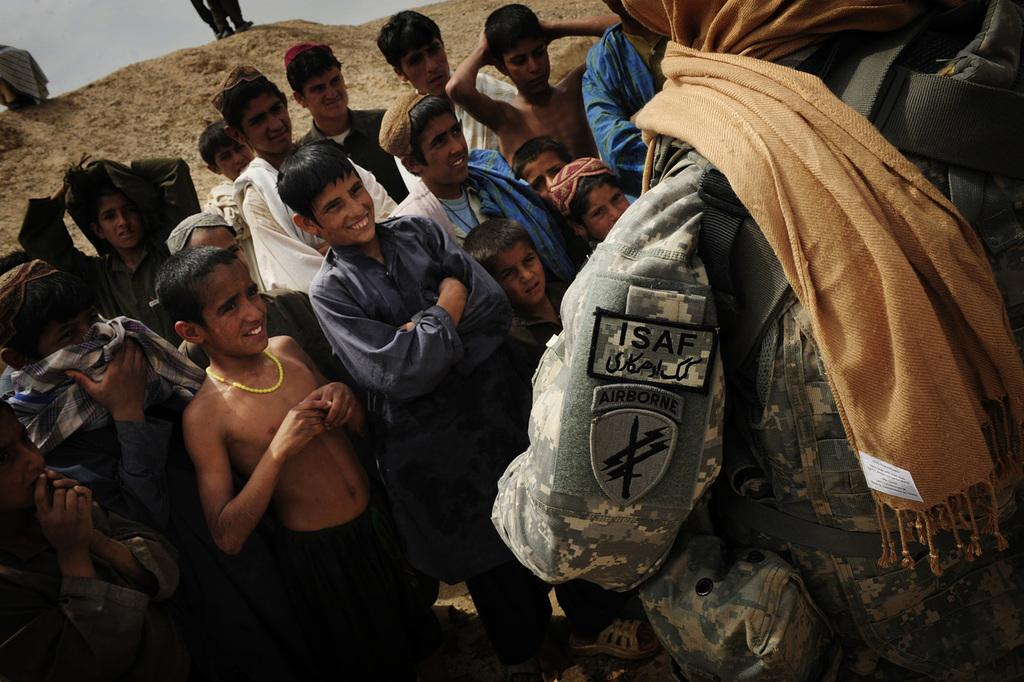Who is present in the image? There are children and a person in the image. What is the setting of the image? The image features a mountain in the background. How many cows are grazing near the children in the image? There are no cows present in the image. What type of border surrounds the mountain in the image? The image does not show a border around the mountain. 